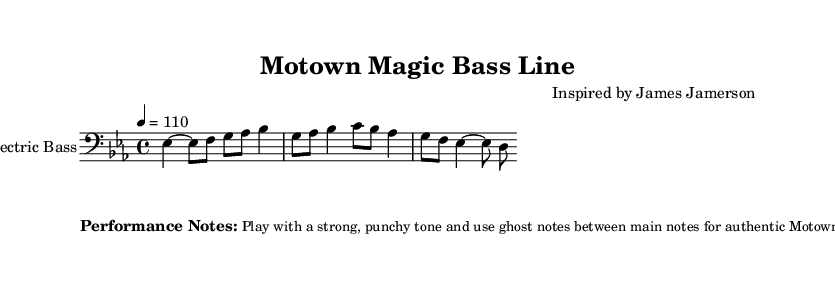What is the key signature of this music? The key signature is E-flat major, which contains three flats (B-flat, E-flat, and A-flat). You can identify the key signature by looking at the first measure before the notes begin.
Answer: E-flat major What is the time signature of this music? The time signature is indicated next to the clef at the beginning of the score. Here, it is 4/4, which means there are four beats per measure and a quarter note receives one beat.
Answer: 4/4 What is the tempo marking for this music? The tempo is specified in beats per minute at the beginning of the score. In this case, it states "4 = 110," indicating that there are 110 quarter note beats per minute.
Answer: 110 Which instrument is this sheet music for? The instrument is identified at the beginning of the staff. It clearly states "Electric Bass," which indicates that the music is written specifically for the bass guitar.
Answer: Electric Bass How many bars are in the melody of this music? To determine the number of bars, you can count the measures in the score. There are 8 measures in total, each separated by vertical bar lines.
Answer: 8 What performance technique is emphasized in the notes? The performance notes suggest to use ghost notes between the main notes for an authentic Motown feel. By playing these muted notes, you enhance the rhythm and groove typical of Motown music.
Answer: Ghost notes Which legendary bassist inspired this piece? The composer credit identifies that the music is "Inspired by James Jamerson." This indicates that the piece draws influence from his iconic style and techniques.
Answer: James Jamerson 